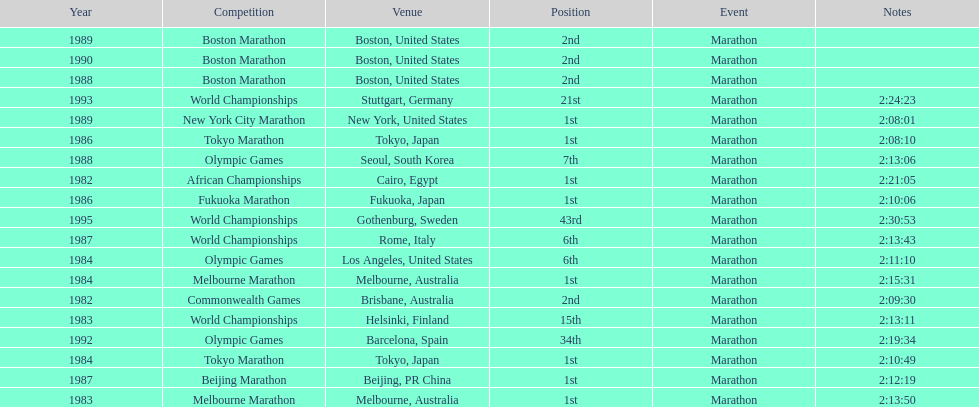Which was the only competition to occur in china? Beijing Marathon. Would you mind parsing the complete table? {'header': ['Year', 'Competition', 'Venue', 'Position', 'Event', 'Notes'], 'rows': [['1989', 'Boston Marathon', 'Boston, United States', '2nd', 'Marathon', ''], ['1990', 'Boston Marathon', 'Boston, United States', '2nd', 'Marathon', ''], ['1988', 'Boston Marathon', 'Boston, United States', '2nd', 'Marathon', ''], ['1993', 'World Championships', 'Stuttgart, Germany', '21st', 'Marathon', '2:24:23'], ['1989', 'New York City Marathon', 'New York, United States', '1st', 'Marathon', '2:08:01'], ['1986', 'Tokyo Marathon', 'Tokyo, Japan', '1st', 'Marathon', '2:08:10'], ['1988', 'Olympic Games', 'Seoul, South Korea', '7th', 'Marathon', '2:13:06'], ['1982', 'African Championships', 'Cairo, Egypt', '1st', 'Marathon', '2:21:05'], ['1986', 'Fukuoka Marathon', 'Fukuoka, Japan', '1st', 'Marathon', '2:10:06'], ['1995', 'World Championships', 'Gothenburg, Sweden', '43rd', 'Marathon', '2:30:53'], ['1987', 'World Championships', 'Rome, Italy', '6th', 'Marathon', '2:13:43'], ['1984', 'Olympic Games', 'Los Angeles, United States', '6th', 'Marathon', '2:11:10'], ['1984', 'Melbourne Marathon', 'Melbourne, Australia', '1st', 'Marathon', '2:15:31'], ['1982', 'Commonwealth Games', 'Brisbane, Australia', '2nd', 'Marathon', '2:09:30'], ['1983', 'World Championships', 'Helsinki, Finland', '15th', 'Marathon', '2:13:11'], ['1992', 'Olympic Games', 'Barcelona, Spain', '34th', 'Marathon', '2:19:34'], ['1984', 'Tokyo Marathon', 'Tokyo, Japan', '1st', 'Marathon', '2:10:49'], ['1987', 'Beijing Marathon', 'Beijing, PR China', '1st', 'Marathon', '2:12:19'], ['1983', 'Melbourne Marathon', 'Melbourne, Australia', '1st', 'Marathon', '2:13:50']]} 